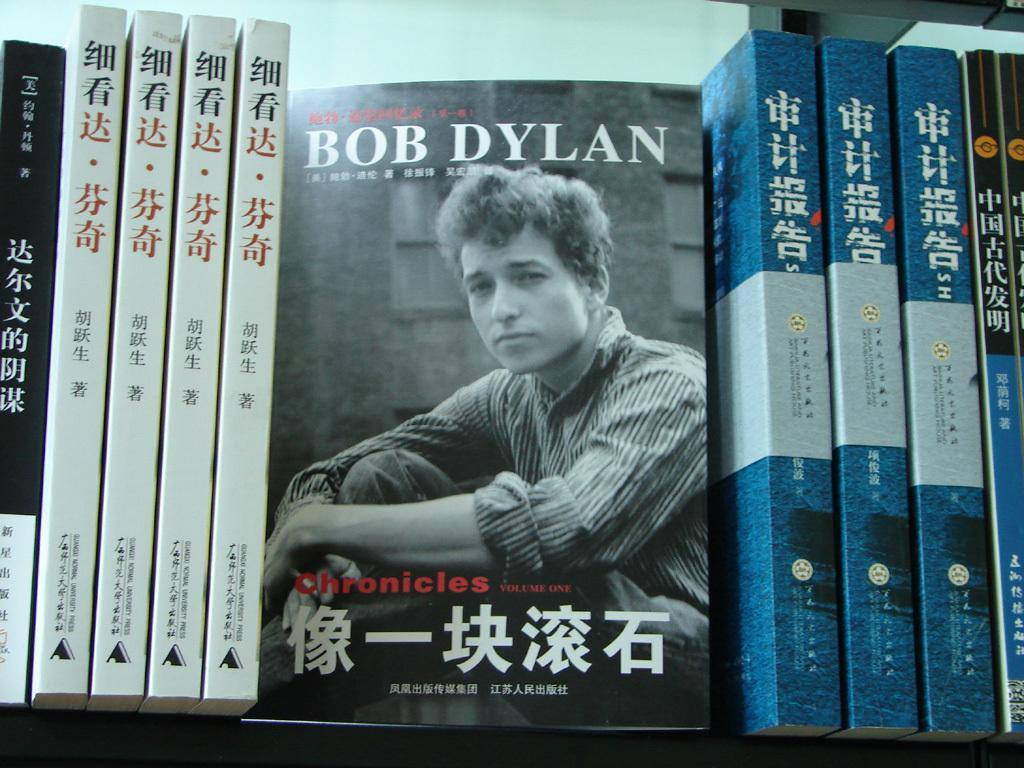<image>
Present a compact description of the photo's key features. book with bob dylan at top with a photo of him beneath and asian writing at bottem and other asian books on left and right of it 